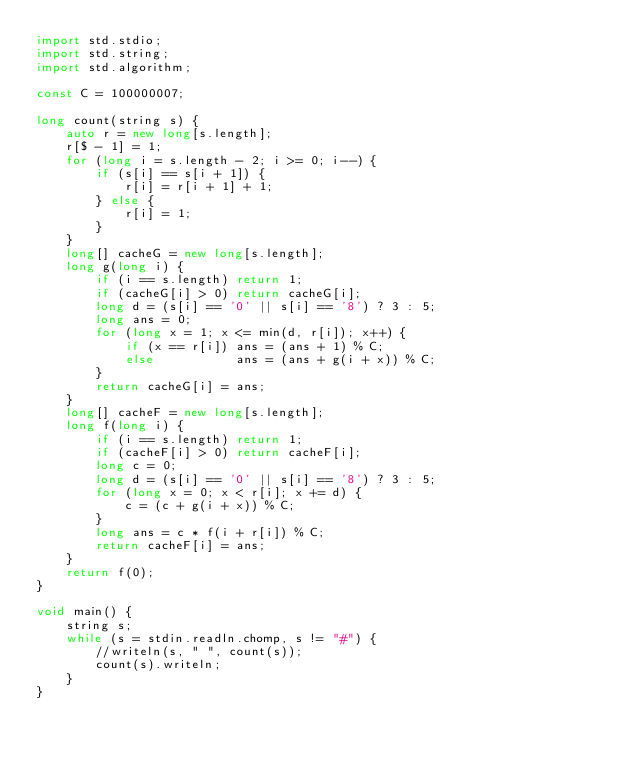<code> <loc_0><loc_0><loc_500><loc_500><_D_>import std.stdio;
import std.string;
import std.algorithm;

const C = 100000007;

long count(string s) {
    auto r = new long[s.length];
    r[$ - 1] = 1;
    for (long i = s.length - 2; i >= 0; i--) {
        if (s[i] == s[i + 1]) {
            r[i] = r[i + 1] + 1;
        } else {
            r[i] = 1;
        }
    }
    long[] cacheG = new long[s.length];
    long g(long i) {
        if (i == s.length) return 1;
        if (cacheG[i] > 0) return cacheG[i];
        long d = (s[i] == '0' || s[i] == '8') ? 3 : 5;
        long ans = 0;
        for (long x = 1; x <= min(d, r[i]); x++) {
            if (x == r[i]) ans = (ans + 1) % C;
            else           ans = (ans + g(i + x)) % C;
        }
        return cacheG[i] = ans;
    }
    long[] cacheF = new long[s.length];
    long f(long i) {
        if (i == s.length) return 1;
        if (cacheF[i] > 0) return cacheF[i];
        long c = 0;
        long d = (s[i] == '0' || s[i] == '8') ? 3 : 5;
        for (long x = 0; x < r[i]; x += d) {
            c = (c + g(i + x)) % C;
        }
        long ans = c * f(i + r[i]) % C;
        return cacheF[i] = ans;
    }
    return f(0);
}

void main() {
    string s;
    while (s = stdin.readln.chomp, s != "#") {
        //writeln(s, " ", count(s));
        count(s).writeln;
    }
}</code> 